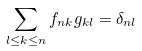<formula> <loc_0><loc_0><loc_500><loc_500>\sum _ { l \leq k \leq n } f _ { n k } g _ { k l } = \delta _ { n l }</formula> 